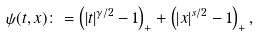<formula> <loc_0><loc_0><loc_500><loc_500>\psi ( t , x ) \colon = \left ( | t | ^ { \gamma / 2 } - 1 \right ) _ { + } + \left ( | x | ^ { s / 2 } - 1 \right ) _ { + } ,</formula> 